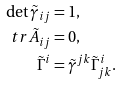Convert formula to latex. <formula><loc_0><loc_0><loc_500><loc_500>\det \tilde { \gamma } _ { i j } & = 1 , \\ \ t r \tilde { A } _ { i j } & = 0 , \\ \tilde { \Gamma } ^ { i } & = \tilde { \gamma } ^ { j k } \tilde { \Gamma } ^ { i } _ { j k } .</formula> 